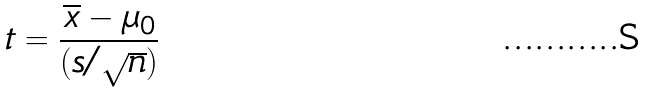Convert formula to latex. <formula><loc_0><loc_0><loc_500><loc_500>t = \frac { \overline { x } - \mu _ { 0 } } { ( s / \sqrt { n } ) }</formula> 